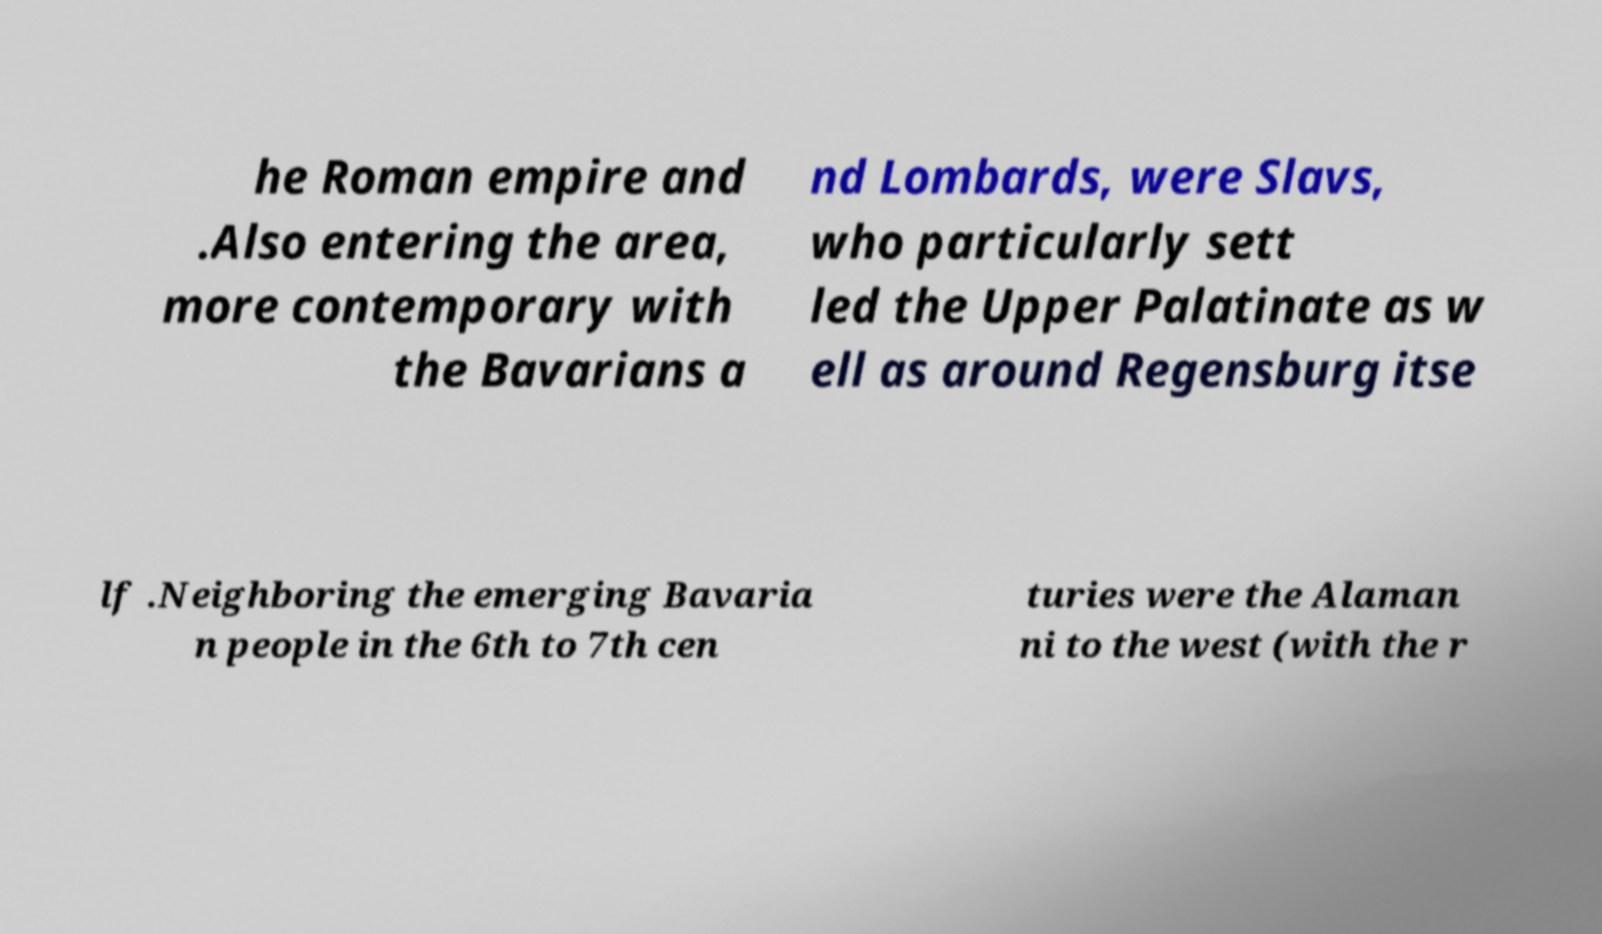What messages or text are displayed in this image? I need them in a readable, typed format. he Roman empire and .Also entering the area, more contemporary with the Bavarians a nd Lombards, were Slavs, who particularly sett led the Upper Palatinate as w ell as around Regensburg itse lf .Neighboring the emerging Bavaria n people in the 6th to 7th cen turies were the Alaman ni to the west (with the r 